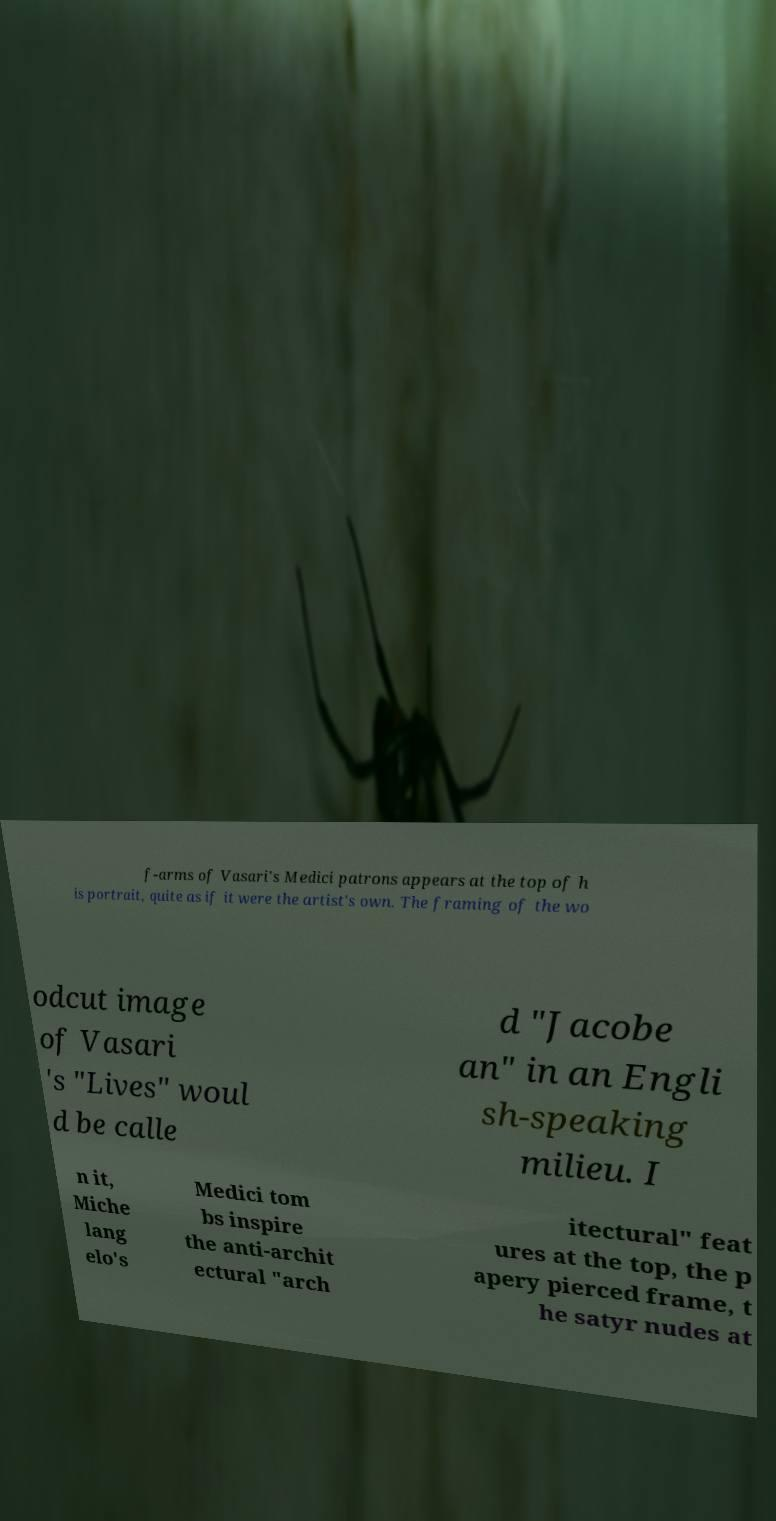Could you extract and type out the text from this image? f-arms of Vasari's Medici patrons appears at the top of h is portrait, quite as if it were the artist's own. The framing of the wo odcut image of Vasari 's "Lives" woul d be calle d "Jacobe an" in an Engli sh-speaking milieu. I n it, Miche lang elo's Medici tom bs inspire the anti-archit ectural "arch itectural" feat ures at the top, the p apery pierced frame, t he satyr nudes at 